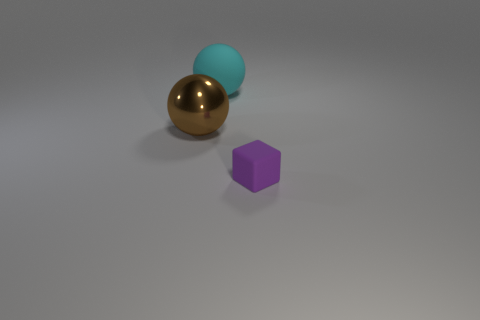The thing that is both to the left of the small object and right of the brown sphere has what shape?
Provide a short and direct response. Sphere. Is the number of objects that are behind the brown sphere greater than the number of tiny red shiny cylinders?
Keep it short and to the point. Yes. There is a cyan object that is made of the same material as the tiny purple object; what size is it?
Give a very brief answer. Large. What number of big rubber spheres have the same color as the matte block?
Keep it short and to the point. 0. There is a tiny rubber block that is on the right side of the brown metal thing; does it have the same color as the metallic object?
Your answer should be very brief. No. Is the number of small cubes that are right of the tiny object the same as the number of brown balls that are behind the brown ball?
Offer a very short reply. Yes. Is there any other thing that is made of the same material as the tiny purple cube?
Your response must be concise. Yes. What is the color of the rubber thing that is to the left of the small rubber block?
Your answer should be very brief. Cyan. Are there the same number of large cyan balls in front of the large matte ball and cyan matte spheres?
Ensure brevity in your answer.  No. What number of other things are the same shape as the large brown metallic thing?
Your answer should be very brief. 1. 